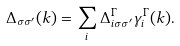<formula> <loc_0><loc_0><loc_500><loc_500>\Delta _ { \sigma \sigma ^ { \prime } } ( { k } ) = \sum _ { i } \Delta ^ { \Gamma } _ { i \sigma \sigma ^ { \prime } } \gamma ^ { \Gamma } _ { i } ( { k } ) .</formula> 